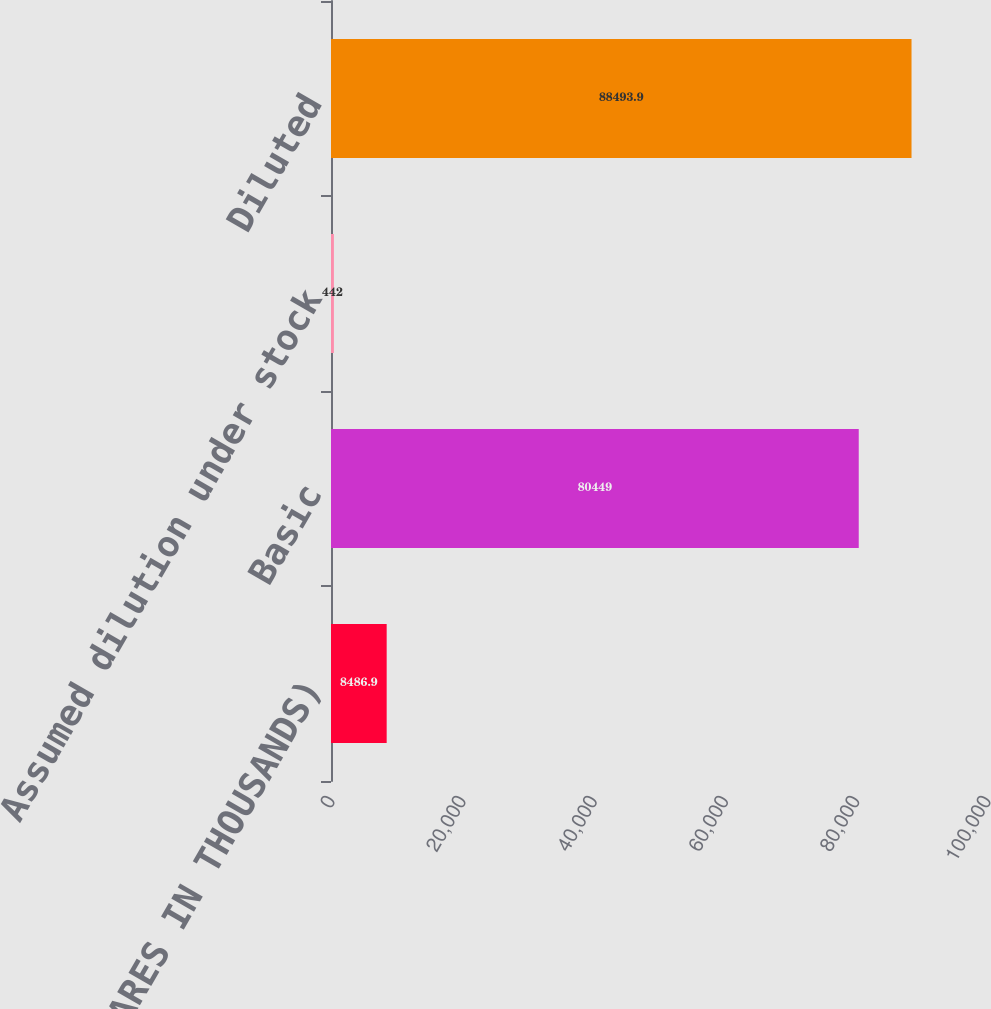<chart> <loc_0><loc_0><loc_500><loc_500><bar_chart><fcel>(SHARES IN THOUSANDS)<fcel>Basic<fcel>Assumed dilution under stock<fcel>Diluted<nl><fcel>8486.9<fcel>80449<fcel>442<fcel>88493.9<nl></chart> 